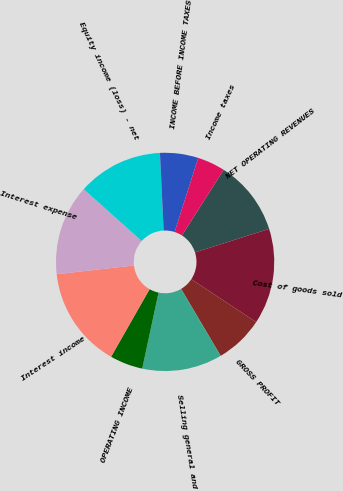Convert chart. <chart><loc_0><loc_0><loc_500><loc_500><pie_chart><fcel>NET OPERATING REVENUES<fcel>Cost of goods sold<fcel>GROSS PROFIT<fcel>Selling general and<fcel>OPERATING INCOME<fcel>Interest income<fcel>Interest expense<fcel>Equity income (loss) - net<fcel>INCOME BEFORE INCOME TAXES<fcel>Income taxes<nl><fcel>11.09%<fcel>14.19%<fcel>7.21%<fcel>11.86%<fcel>4.88%<fcel>14.96%<fcel>13.41%<fcel>12.64%<fcel>5.66%<fcel>4.11%<nl></chart> 